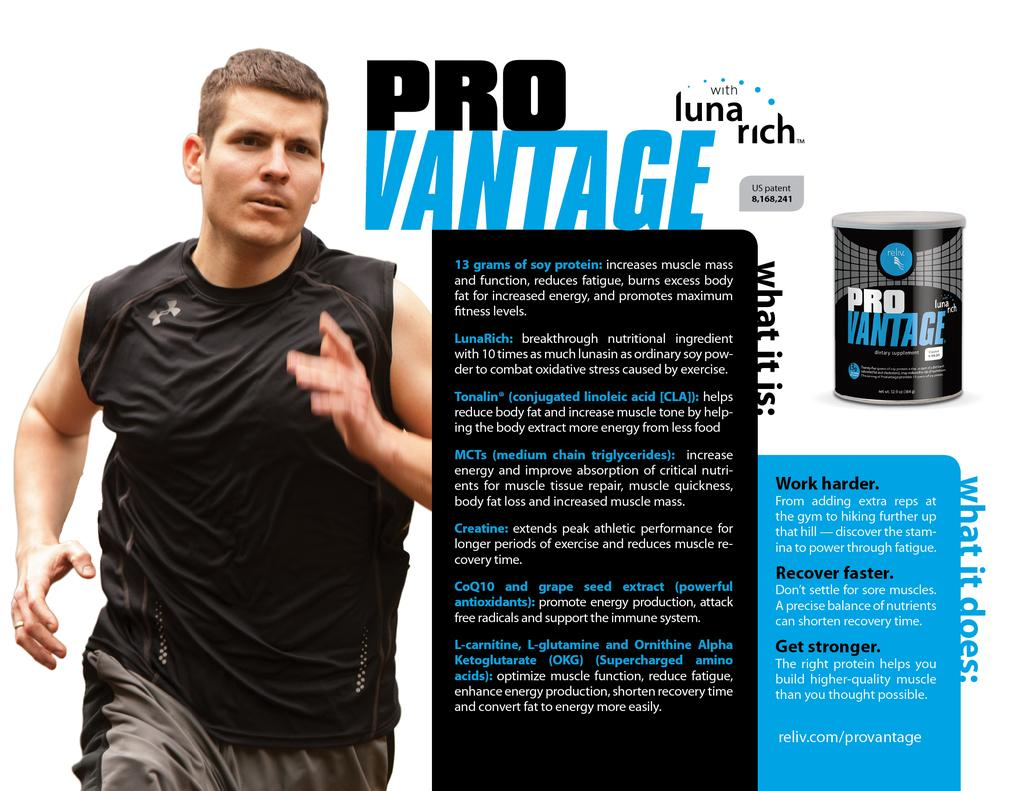What is present on the poster in the image? There is a poster in the image, and there is text on the poster. What other object can be seen in the image? There is a box in the image. Can you describe the person in the image? There is a person in the image, but their specific characteristics are not mentioned in the facts. What might the text on the poster be about? The facts do not provide information about the content of the text on the poster. What type of religion is practiced by the giants in the image? There are no giants or any reference to religion present in the image. Who is the writer of the text on the poster in the image? The facts do not provide information about the author of the text on the poster. 